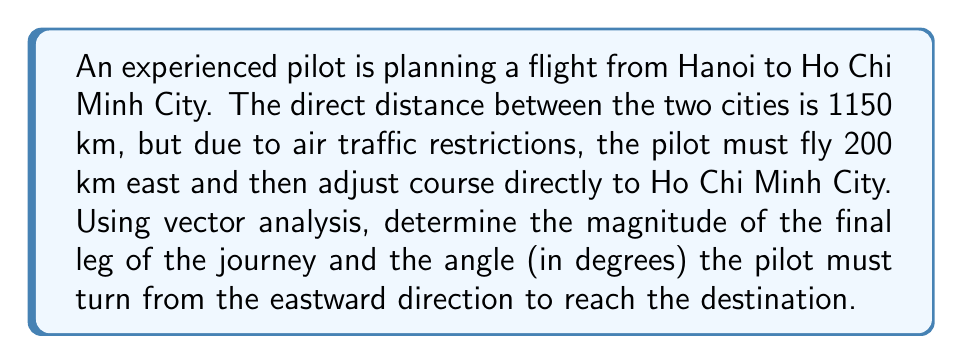What is the answer to this math problem? Let's approach this step-by-step using vector analysis:

1) First, let's define our vectors:
   - Let $\vec{a}$ be the 200 km eastward vector
   - Let $\vec{b}$ be the vector from the end of $\vec{a}$ to Ho Chi Minh City
   - Let $\vec{c}$ be the direct vector from Hanoi to Ho Chi Minh City

2) We know that $\vec{a} + \vec{b} = \vec{c}$

3) We can represent this in 2D coordinates:
   $\vec{a} = (200, 0)$
   $\vec{c} = (1150\cos\theta, 1150\sin\theta)$, where $\theta$ is the angle between the east direction and the direct path

4) From the vector addition:
   $\vec{b} = \vec{c} - \vec{a} = (1150\cos\theta - 200, 1150\sin\theta)$

5) To find the magnitude of $\vec{b}$, we use the Pythagorean theorem:
   $|\vec{b}| = \sqrt{(1150\cos\theta - 200)^2 + (1150\sin\theta)^2}$

6) To find $\theta$, we can use the fact that $\vec{a} \cdot \vec{c} = |\vec{a}||\vec{c}|\cos\theta$:
   $200 \cdot 1150 = 200 \cdot 1150 \cos\theta$
   $\cos\theta = \frac{200}{1150} \approx 0.1739$
   $\theta = \arccos(0.1739) \approx 80.0°$

7) Now we can calculate $|\vec{b}|$:
   $|\vec{b}| = \sqrt{(1150\cos80.0° - 200)^2 + (1150\sin80.0°)^2} \approx 1131.7$ km

8) The angle the pilot must turn from the eastward direction is $90° - 80.0° = 10.0°$
Answer: $|\vec{b}| \approx 1131.7$ km, turn angle $\approx 10.0°$ south 